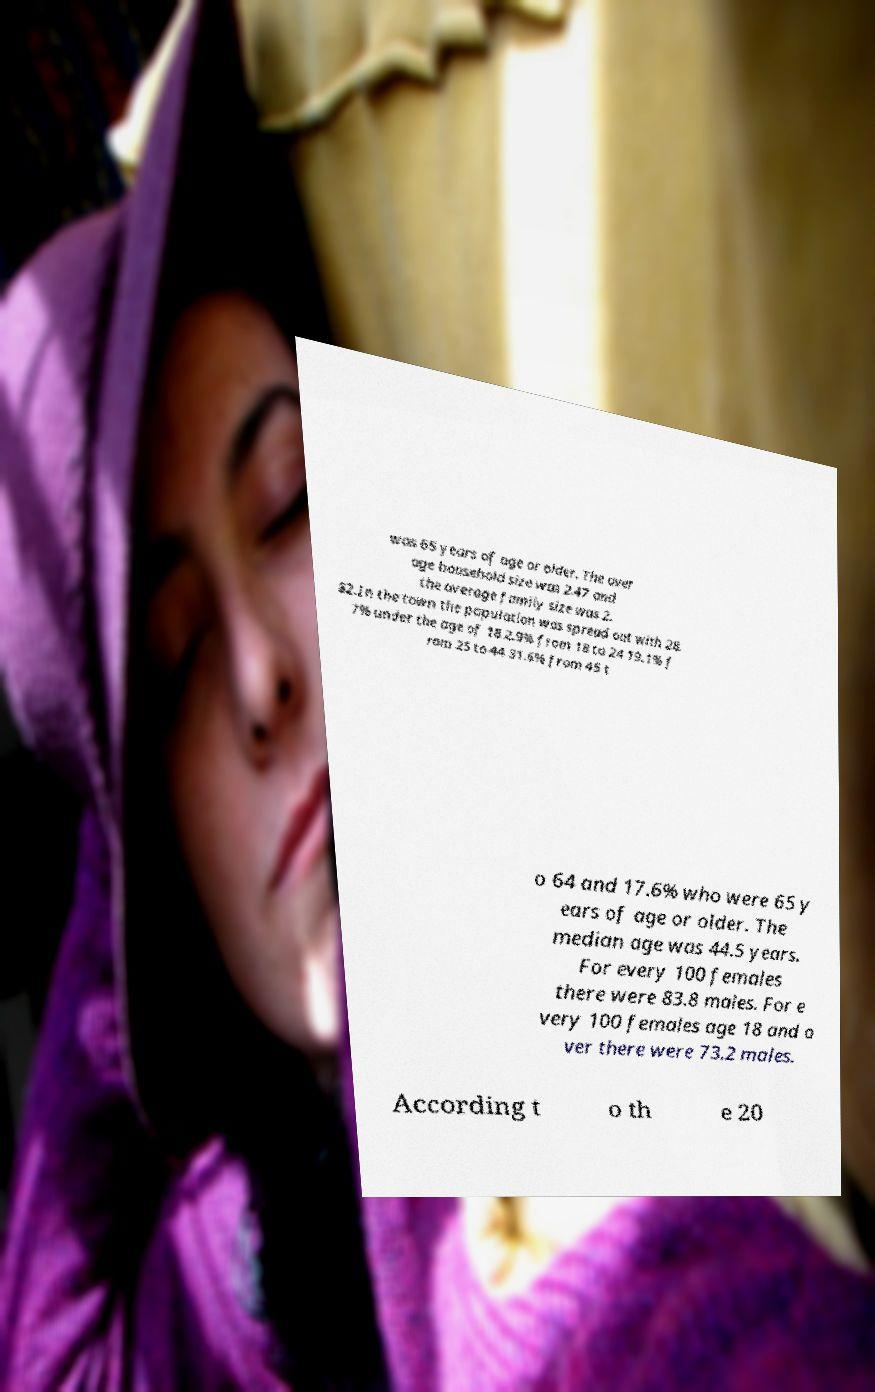Could you extract and type out the text from this image? was 65 years of age or older. The aver age household size was 2.47 and the average family size was 2. 82.In the town the population was spread out with 28. 7% under the age of 18 2.9% from 18 to 24 19.1% f rom 25 to 44 31.6% from 45 t o 64 and 17.6% who were 65 y ears of age or older. The median age was 44.5 years. For every 100 females there were 83.8 males. For e very 100 females age 18 and o ver there were 73.2 males. According t o th e 20 